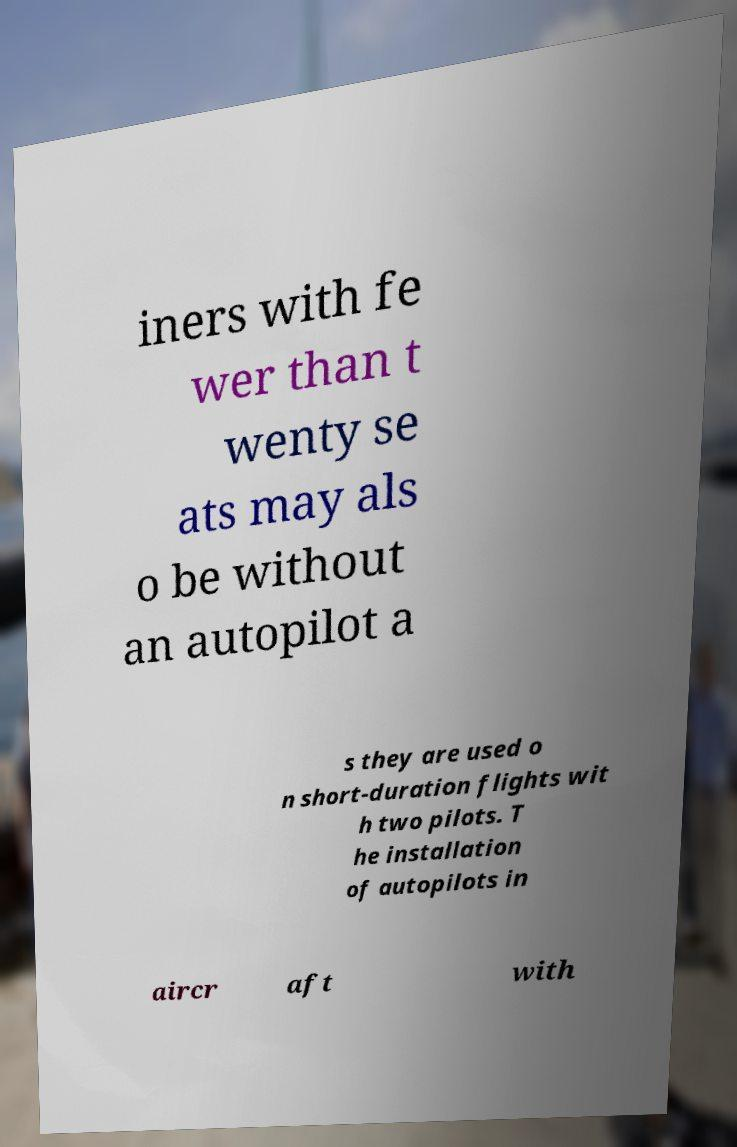Please identify and transcribe the text found in this image. iners with fe wer than t wenty se ats may als o be without an autopilot a s they are used o n short-duration flights wit h two pilots. T he installation of autopilots in aircr aft with 